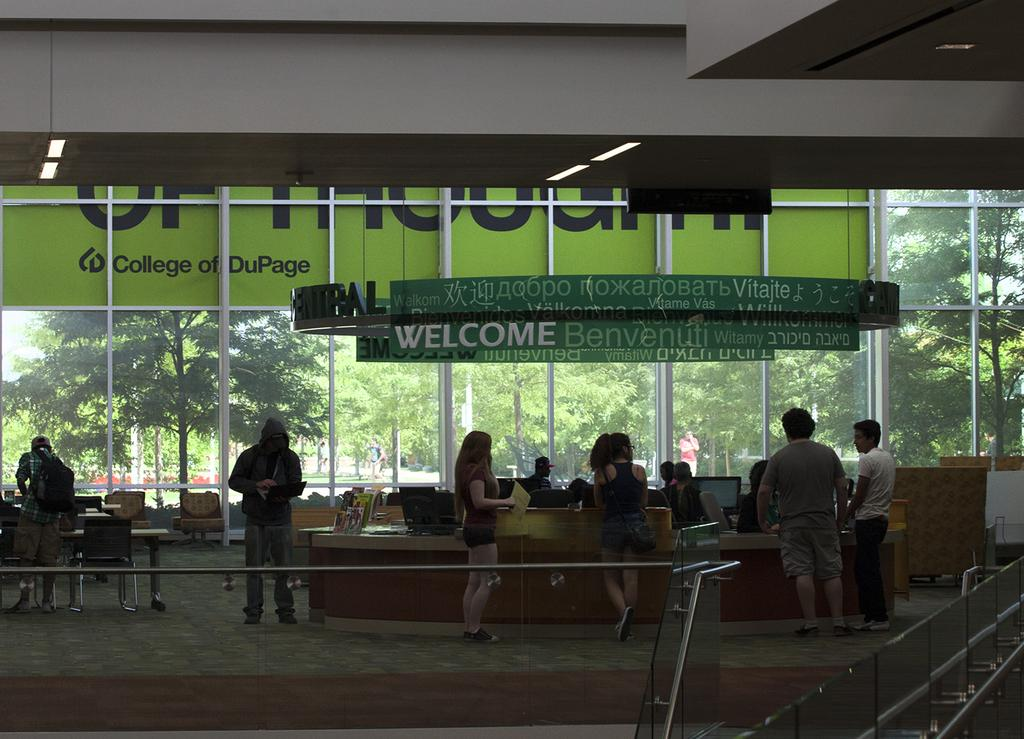Who or what can be seen in the image? There are people in the image. What can be seen in the distance behind the people? There are trees and a board in the background of the image. What type of thought can be seen floating above the people's heads in the image? There are no thoughts visible in the image; it only shows people and the background. 